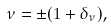<formula> <loc_0><loc_0><loc_500><loc_500>\nu = \pm ( 1 + \delta _ { \nu } ) ,</formula> 